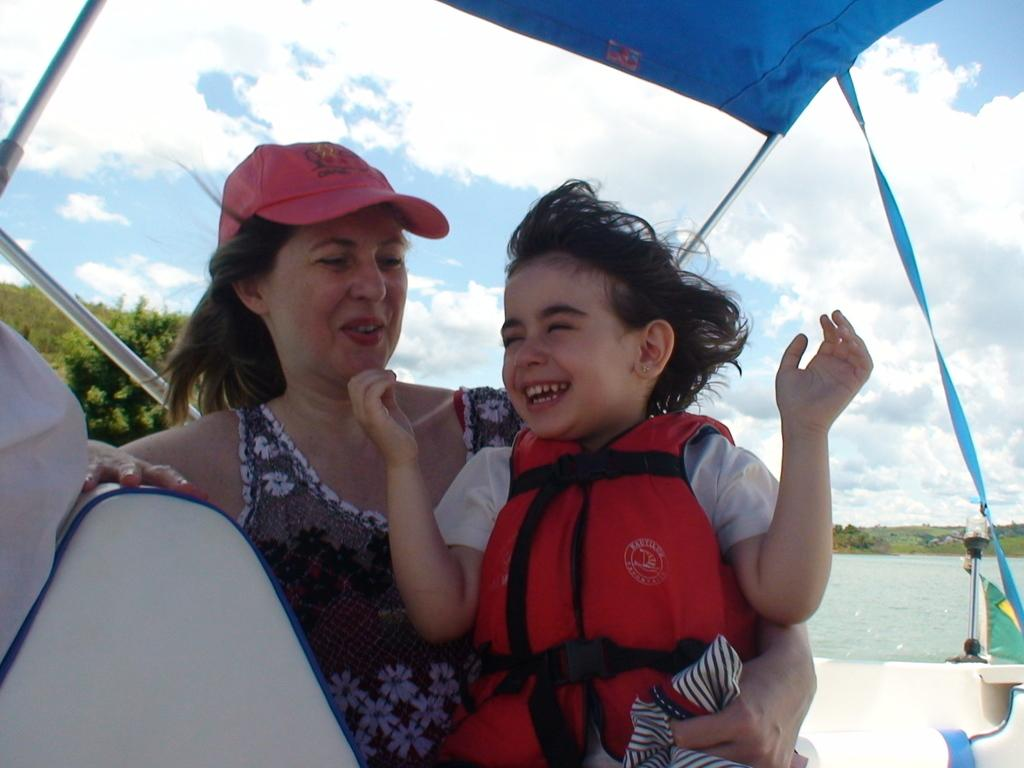What is the woman in the image doing? The woman is holding a child in the image. What structure can be seen in the image? There is a tent with poles in the image. What can be seen in the distance in the image? There is a water body and a group of trees visible in the background. How would you describe the sky in the image? The sky is visible and appears cloudy. What type of knee injury does the farmer have in the image? There is no farmer present in the image, and therefore no information about any knee injuries. 